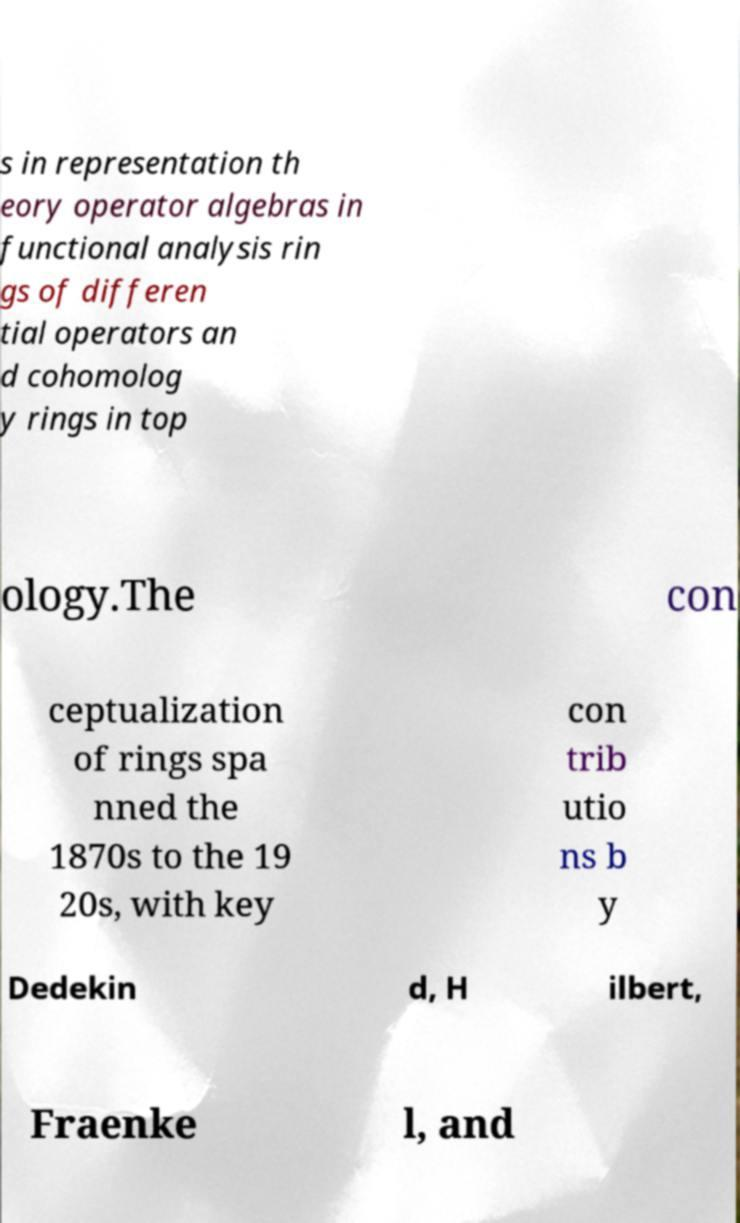Can you accurately transcribe the text from the provided image for me? s in representation th eory operator algebras in functional analysis rin gs of differen tial operators an d cohomolog y rings in top ology.The con ceptualization of rings spa nned the 1870s to the 19 20s, with key con trib utio ns b y Dedekin d, H ilbert, Fraenke l, and 